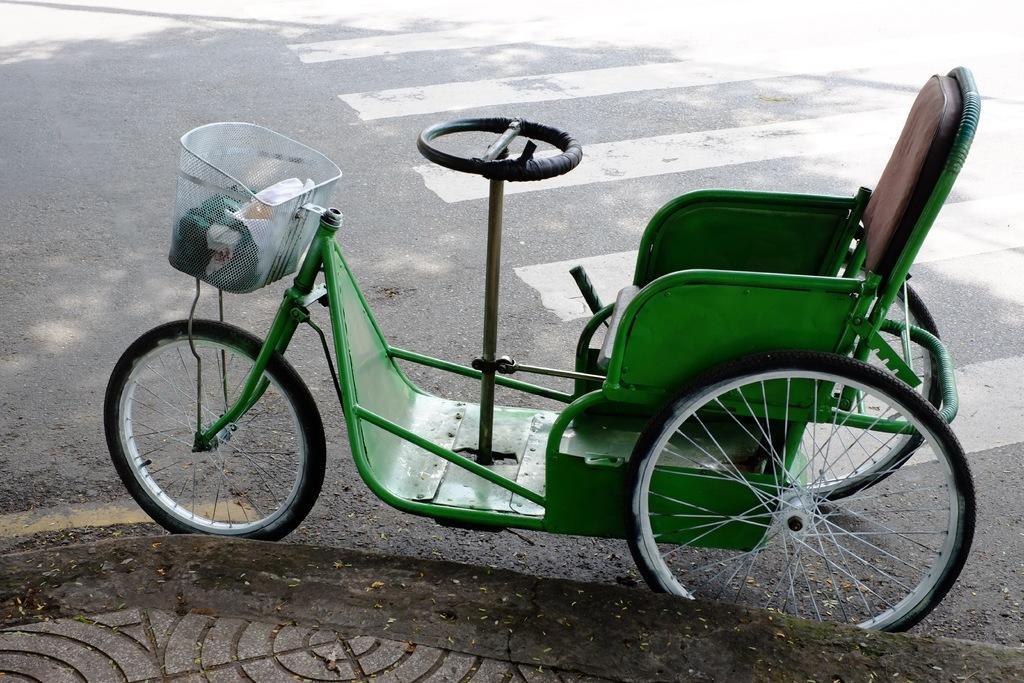In one or two sentences, can you explain what this image depicts? In this picture we can see a green color tricycle on the road. 